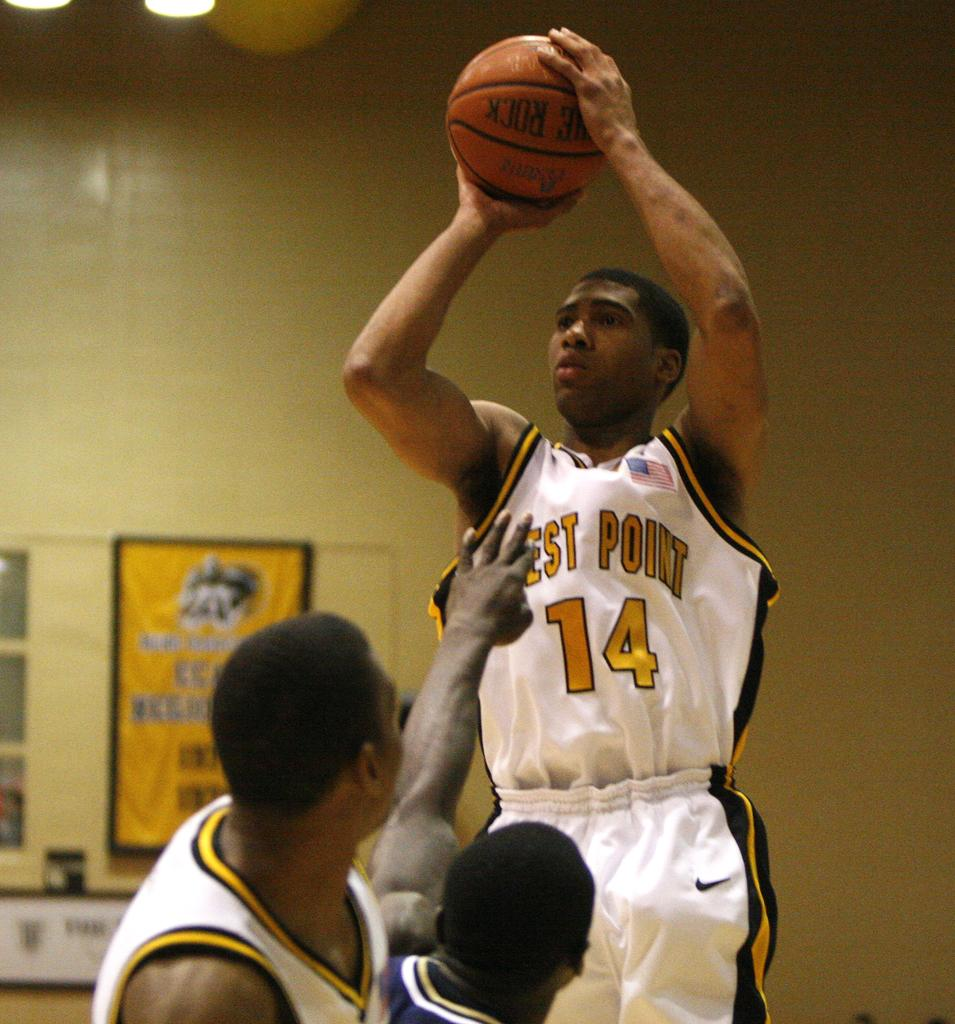<image>
Create a compact narrative representing the image presented. The player for West Point jumps up to shoot the basketball. 